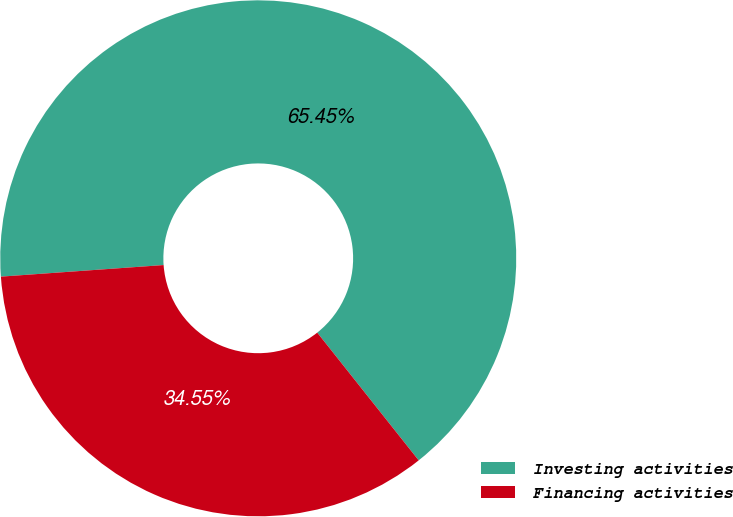Convert chart to OTSL. <chart><loc_0><loc_0><loc_500><loc_500><pie_chart><fcel>Investing activities<fcel>Financing activities<nl><fcel>65.45%<fcel>34.55%<nl></chart> 